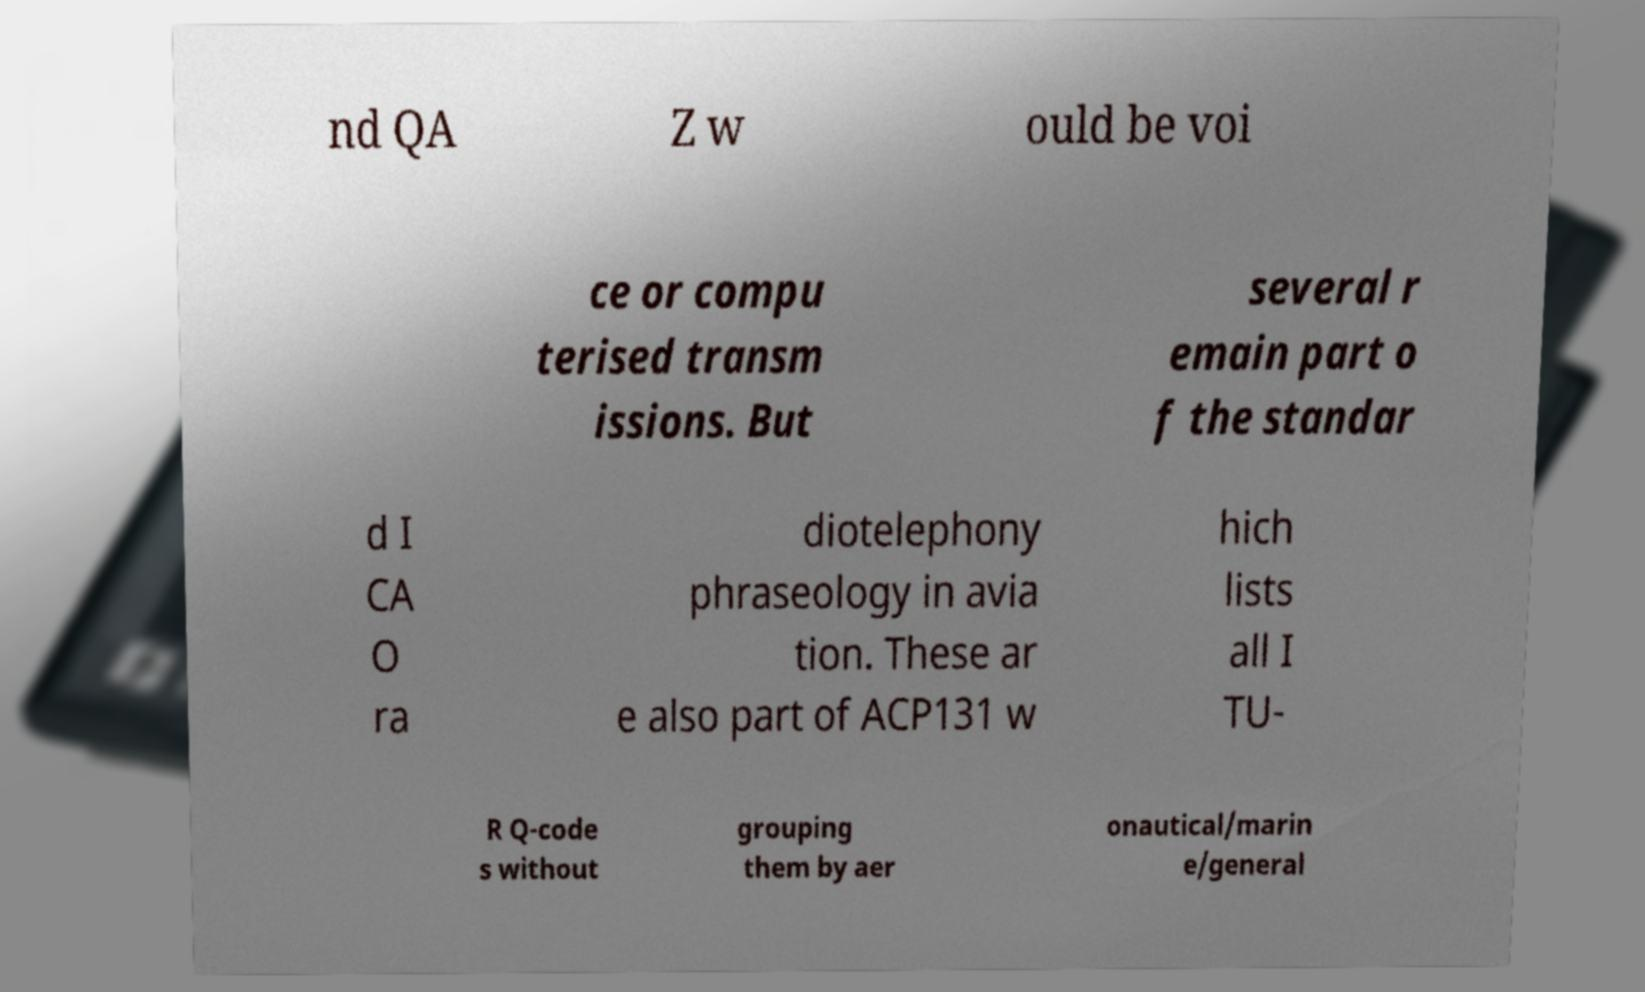Please identify and transcribe the text found in this image. nd QA Z w ould be voi ce or compu terised transm issions. But several r emain part o f the standar d I CA O ra diotelephony phraseology in avia tion. These ar e also part of ACP131 w hich lists all I TU- R Q-code s without grouping them by aer onautical/marin e/general 